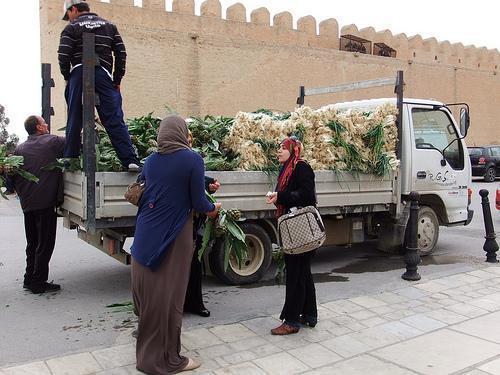How many panel trucks are visible?
Give a very brief answer. 1. How many people are standing in the truck?
Give a very brief answer. 1. 